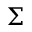<formula> <loc_0><loc_0><loc_500><loc_500>\Sigma</formula> 